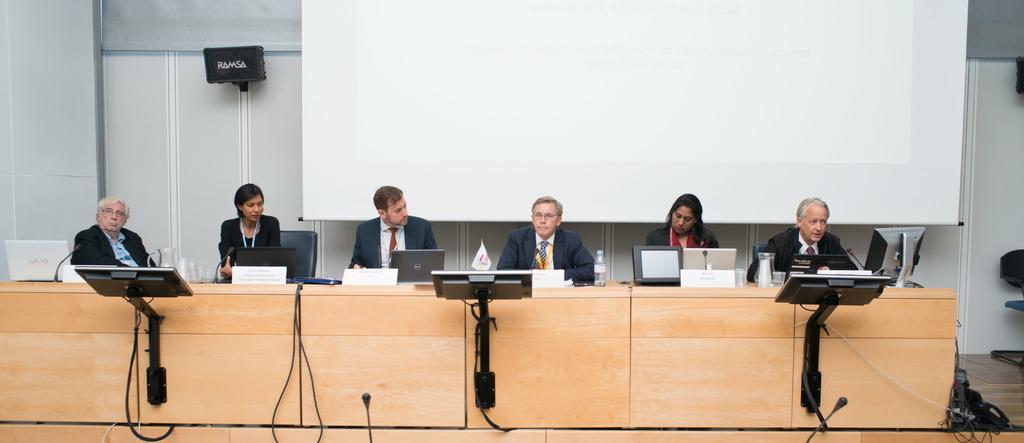Describe this image in one or two sentences. In this image we can see many persons sitting at the table. On the table we can see laptop's, mic, water bottle and flag. In the background we can see speaker, screen and wall. At the bottom of the image we can see mice and screens. 